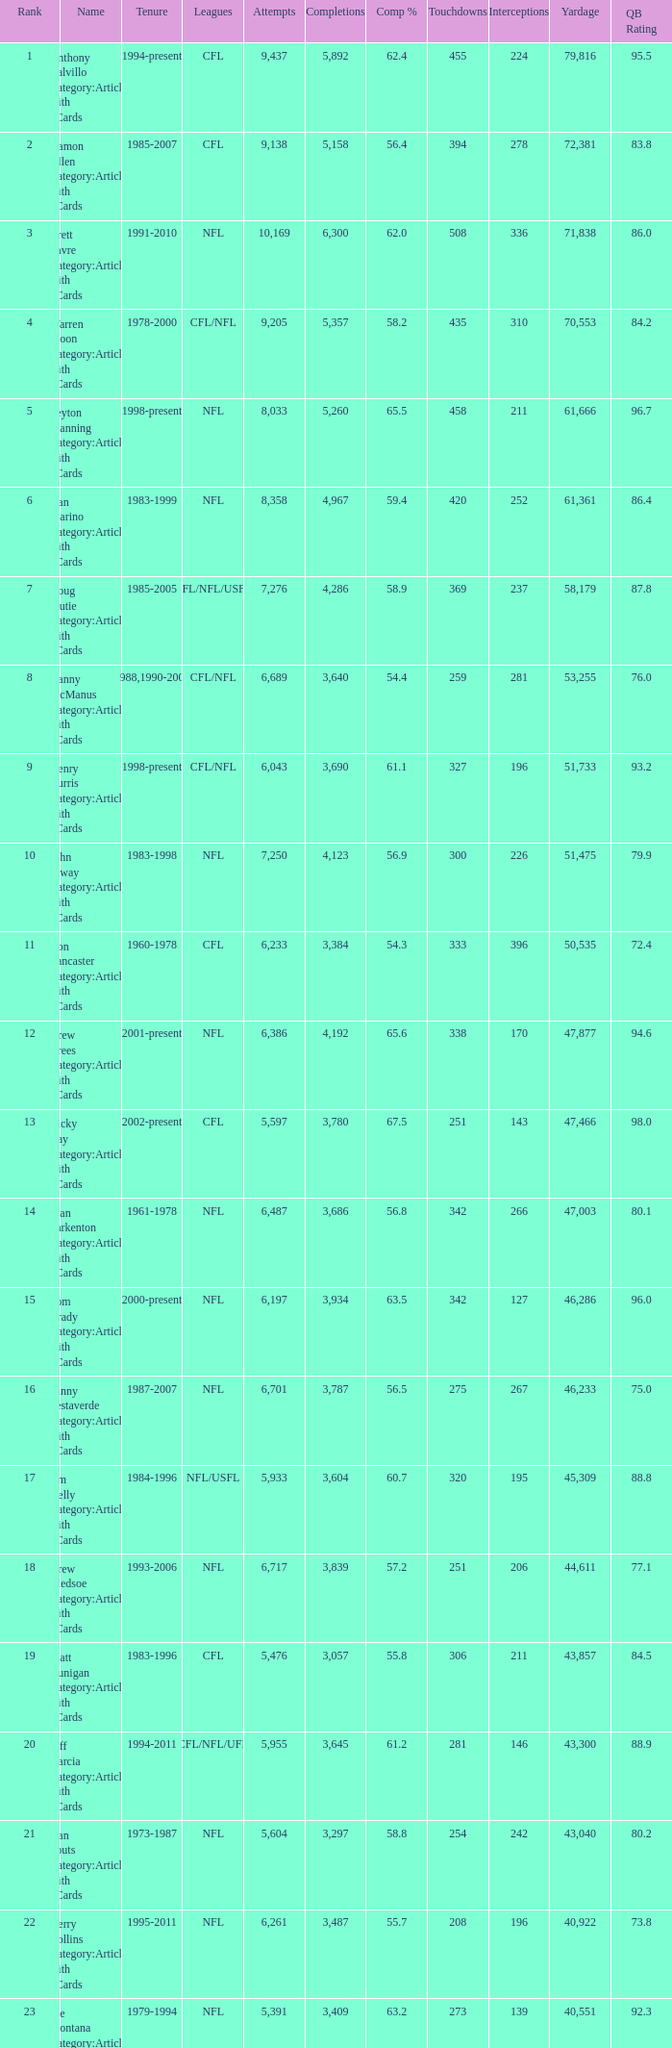What is the rank when there are more than 4,123 completion and the comp percentage is more than 65.6? None. 